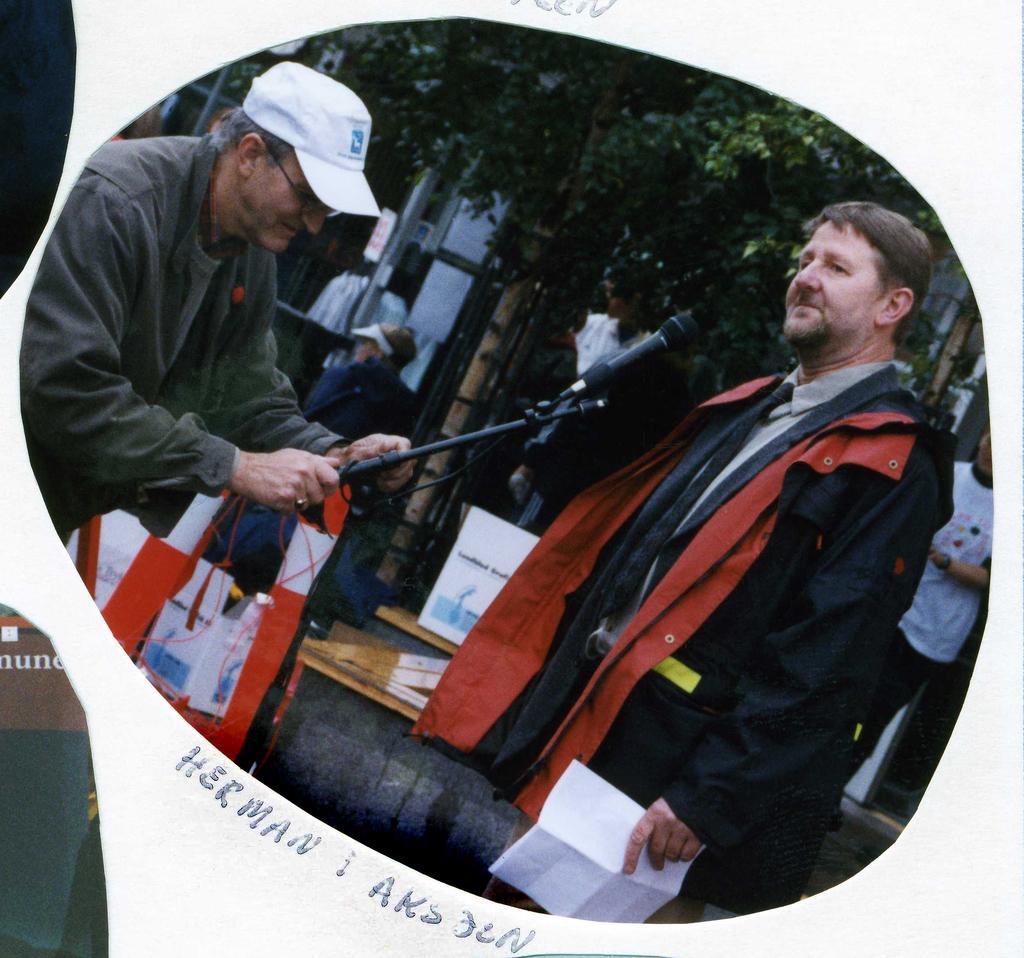Please provide a concise description of this image. In this image, on the right side, we can see a man standing and holding a paper, on the left side, we can see a man holding a microphone, he is wearing a white color hat, in the background we can see some people and there are some trees. 